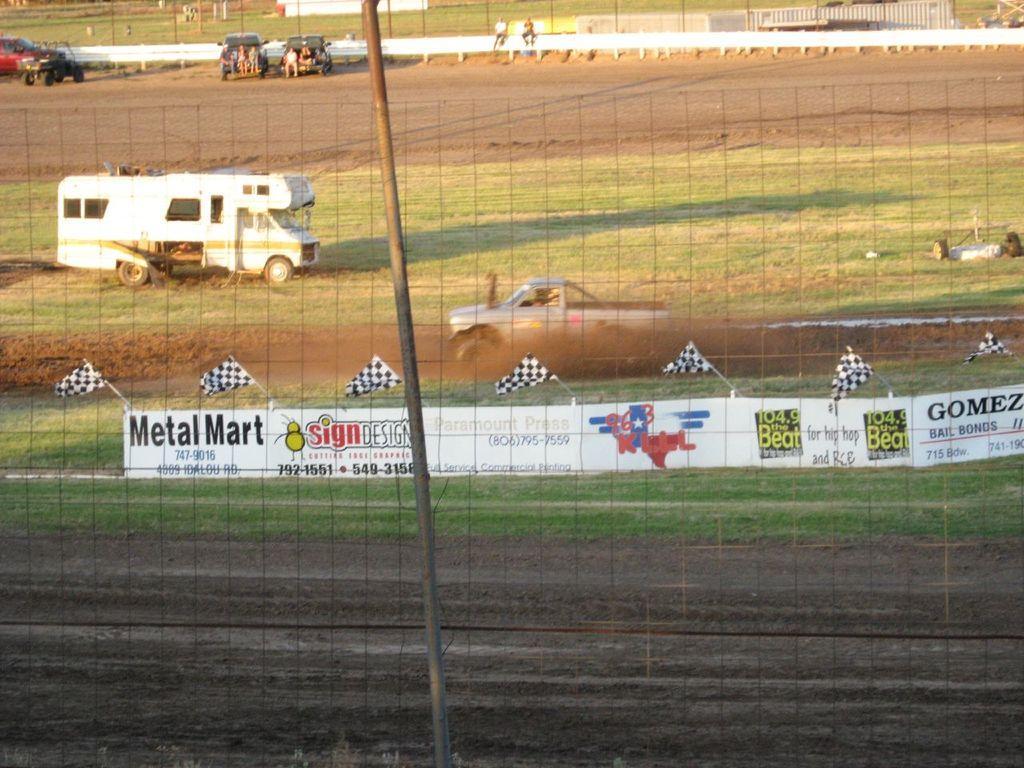How would you summarize this image in a sentence or two? In this image in the front there is a pole in the center there is a fence and there are boards with some text written on it and on the top of the boards there are flags. In the background there are vehicles and there are persons, poles and there's grass on the ground. 